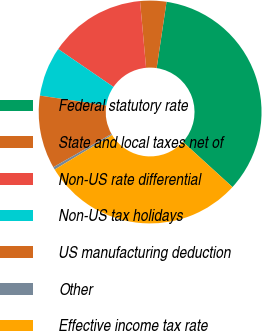Convert chart to OTSL. <chart><loc_0><loc_0><loc_500><loc_500><pie_chart><fcel>Federal statutory rate<fcel>State and local taxes net of<fcel>Non-US rate differential<fcel>Non-US tax holidays<fcel>US manufacturing deduction<fcel>Other<fcel>Effective income tax rate<nl><fcel>34.41%<fcel>3.8%<fcel>14.0%<fcel>7.2%<fcel>10.6%<fcel>0.39%<fcel>29.6%<nl></chart> 